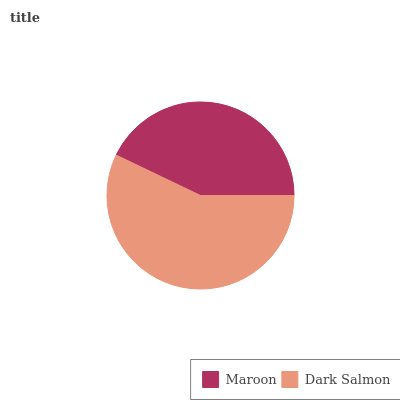Is Maroon the minimum?
Answer yes or no. Yes. Is Dark Salmon the maximum?
Answer yes or no. Yes. Is Dark Salmon the minimum?
Answer yes or no. No. Is Dark Salmon greater than Maroon?
Answer yes or no. Yes. Is Maroon less than Dark Salmon?
Answer yes or no. Yes. Is Maroon greater than Dark Salmon?
Answer yes or no. No. Is Dark Salmon less than Maroon?
Answer yes or no. No. Is Dark Salmon the high median?
Answer yes or no. Yes. Is Maroon the low median?
Answer yes or no. Yes. Is Maroon the high median?
Answer yes or no. No. Is Dark Salmon the low median?
Answer yes or no. No. 